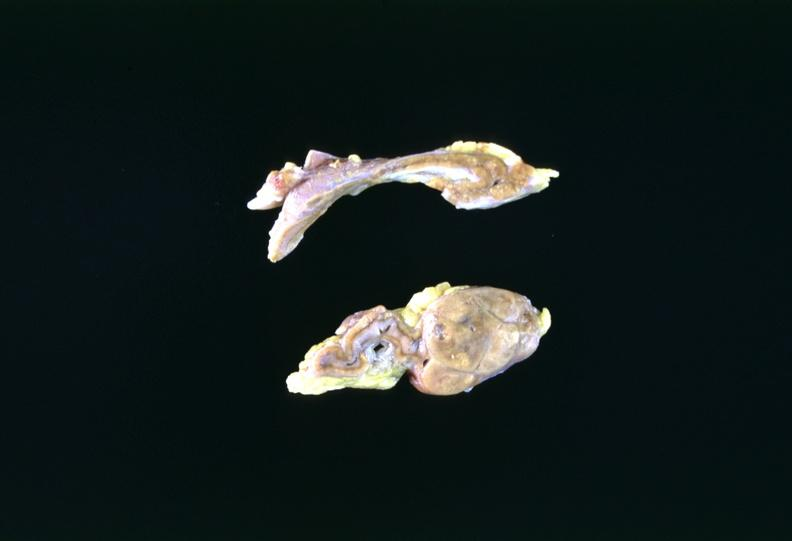what does this image show?
Answer the question using a single word or phrase. Adrenal tumor 